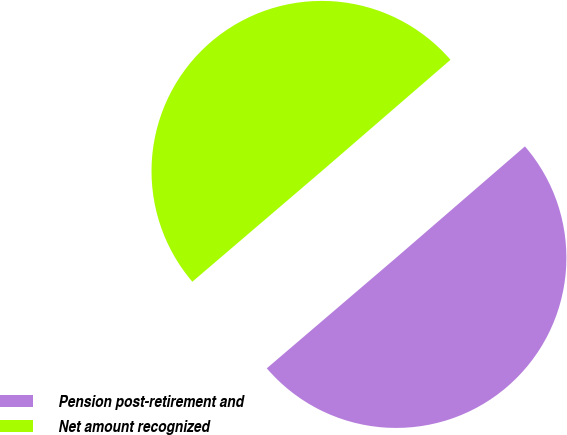<chart> <loc_0><loc_0><loc_500><loc_500><pie_chart><fcel>Pension post-retirement and<fcel>Net amount recognized<nl><fcel>50.09%<fcel>49.91%<nl></chart> 